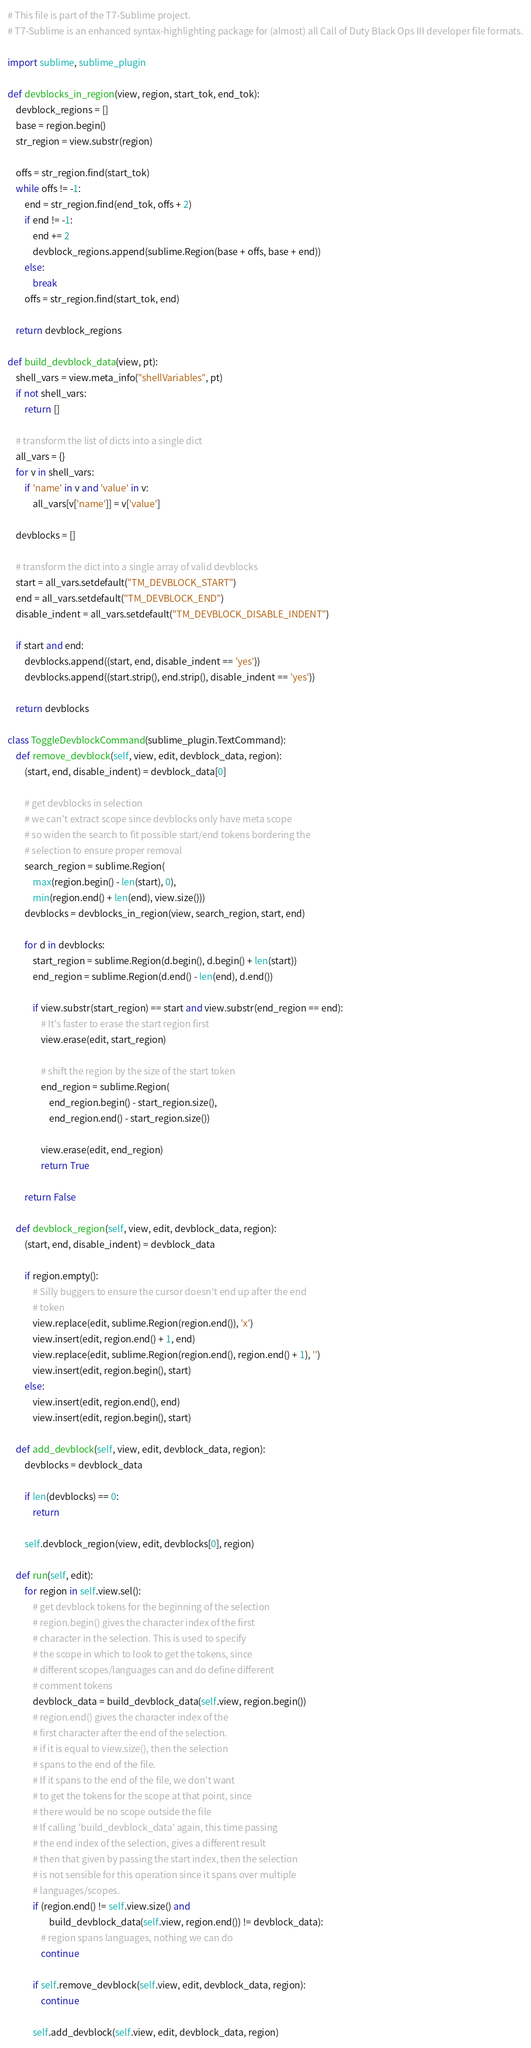<code> <loc_0><loc_0><loc_500><loc_500><_Python_># This file is part of the T7-Sublime project.
# T7-Sublime is an enhanced syntax-highlighting package for (almost) all Call of Duty Black Ops III developer file formats.

import sublime, sublime_plugin

def devblocks_in_region(view, region, start_tok, end_tok):
    devblock_regions = []
    base = region.begin()
    str_region = view.substr(region)

    offs = str_region.find(start_tok)
    while offs != -1:
        end = str_region.find(end_tok, offs + 2)
        if end != -1:
            end += 2
            devblock_regions.append(sublime.Region(base + offs, base + end))
        else:
            break
        offs = str_region.find(start_tok, end)

    return devblock_regions

def build_devblock_data(view, pt):
    shell_vars = view.meta_info("shellVariables", pt)
    if not shell_vars:
        return []

    # transform the list of dicts into a single dict
    all_vars = {}
    for v in shell_vars:
        if 'name' in v and 'value' in v:
            all_vars[v['name']] = v['value']

    devblocks = []

    # transform the dict into a single array of valid devblocks
    start = all_vars.setdefault("TM_DEVBLOCK_START")
    end = all_vars.setdefault("TM_DEVBLOCK_END")
    disable_indent = all_vars.setdefault("TM_DEVBLOCK_DISABLE_INDENT")

    if start and end:
        devblocks.append((start, end, disable_indent == 'yes'))
        devblocks.append((start.strip(), end.strip(), disable_indent == 'yes'))

    return devblocks

class ToggleDevblockCommand(sublime_plugin.TextCommand):
    def remove_devblock(self, view, edit, devblock_data, region):
        (start, end, disable_indent) = devblock_data[0]

        # get devblocks in selection
        # we can't extract scope since devblocks only have meta scope
        # so widen the search to fit possible start/end tokens bordering the
        # selection to ensure proper removal
        search_region = sublime.Region(
            max(region.begin() - len(start), 0),
            min(region.end() + len(end), view.size()))
        devblocks = devblocks_in_region(view, search_region, start, end)

        for d in devblocks:
            start_region = sublime.Region(d.begin(), d.begin() + len(start))
            end_region = sublime.Region(d.end() - len(end), d.end())

            if view.substr(start_region) == start and view.substr(end_region == end):
                # It's faster to erase the start region first
                view.erase(edit, start_region)

                # shift the region by the size of the start token
                end_region = sublime.Region(
                    end_region.begin() - start_region.size(),
                    end_region.end() - start_region.size())

                view.erase(edit, end_region)
                return True

        return False

    def devblock_region(self, view, edit, devblock_data, region):
        (start, end, disable_indent) = devblock_data

        if region.empty():
            # Silly buggers to ensure the cursor doesn't end up after the end
            # token
            view.replace(edit, sublime.Region(region.end()), 'x')
            view.insert(edit, region.end() + 1, end)
            view.replace(edit, sublime.Region(region.end(), region.end() + 1), '')
            view.insert(edit, region.begin(), start)
        else:
            view.insert(edit, region.end(), end)
            view.insert(edit, region.begin(), start)

    def add_devblock(self, view, edit, devblock_data, region):
        devblocks = devblock_data

        if len(devblocks) == 0:
            return

        self.devblock_region(view, edit, devblocks[0], region)

    def run(self, edit):
        for region in self.view.sel():
            # get devblock tokens for the beginning of the selection
            # region.begin() gives the character index of the first
            # character in the selection. This is used to specify
            # the scope in which to look to get the tokens, since
            # different scopes/languages can and do define different
            # comment tokens
            devblock_data = build_devblock_data(self.view, region.begin())
            # region.end() gives the character index of the 
            # first character after the end of the selection.
            # if it is equal to view.size(), then the selection
            # spans to the end of the file.
            # If it spans to the end of the file, we don't want
            # to get the tokens for the scope at that point, since
            # there would be no scope outside the file
            # If calling 'build_devblock_data' again, this time passing
            # the end index of the selection, gives a different result
            # then that given by passing the start index, then the selection
            # is not sensible for this operation since it spans over multiple
            # languages/scopes.
            if (region.end() != self.view.size() and
                    build_devblock_data(self.view, region.end()) != devblock_data):
                # region spans languages, nothing we can do
                continue

            if self.remove_devblock(self.view, edit, devblock_data, region):
                continue

            self.add_devblock(self.view, edit, devblock_data, region)
</code> 